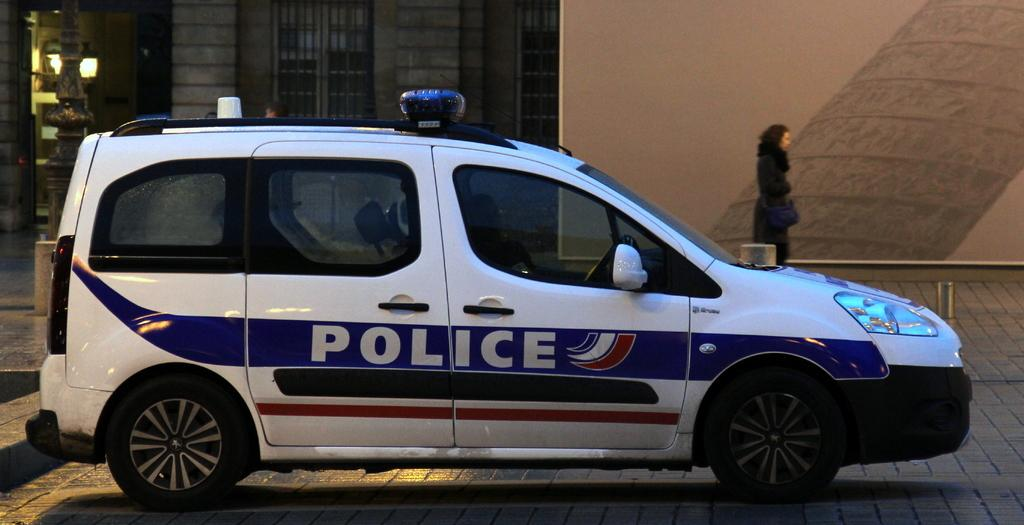What type of vehicle is in the image? There is a police vehicle in the image. Where is the police vehicle located? The police vehicle is parked on land. Is there any additional feature on the vehicle? Yes, there is a compartment behind the vehicle. What else can be seen in the image? A woman is beside a wall on the right side of the image. How many shoes can be seen in the image? There is no shoe present in the image. What is the level of noise in the image? The level of noise cannot be determined from the image, as it is a still photograph. 